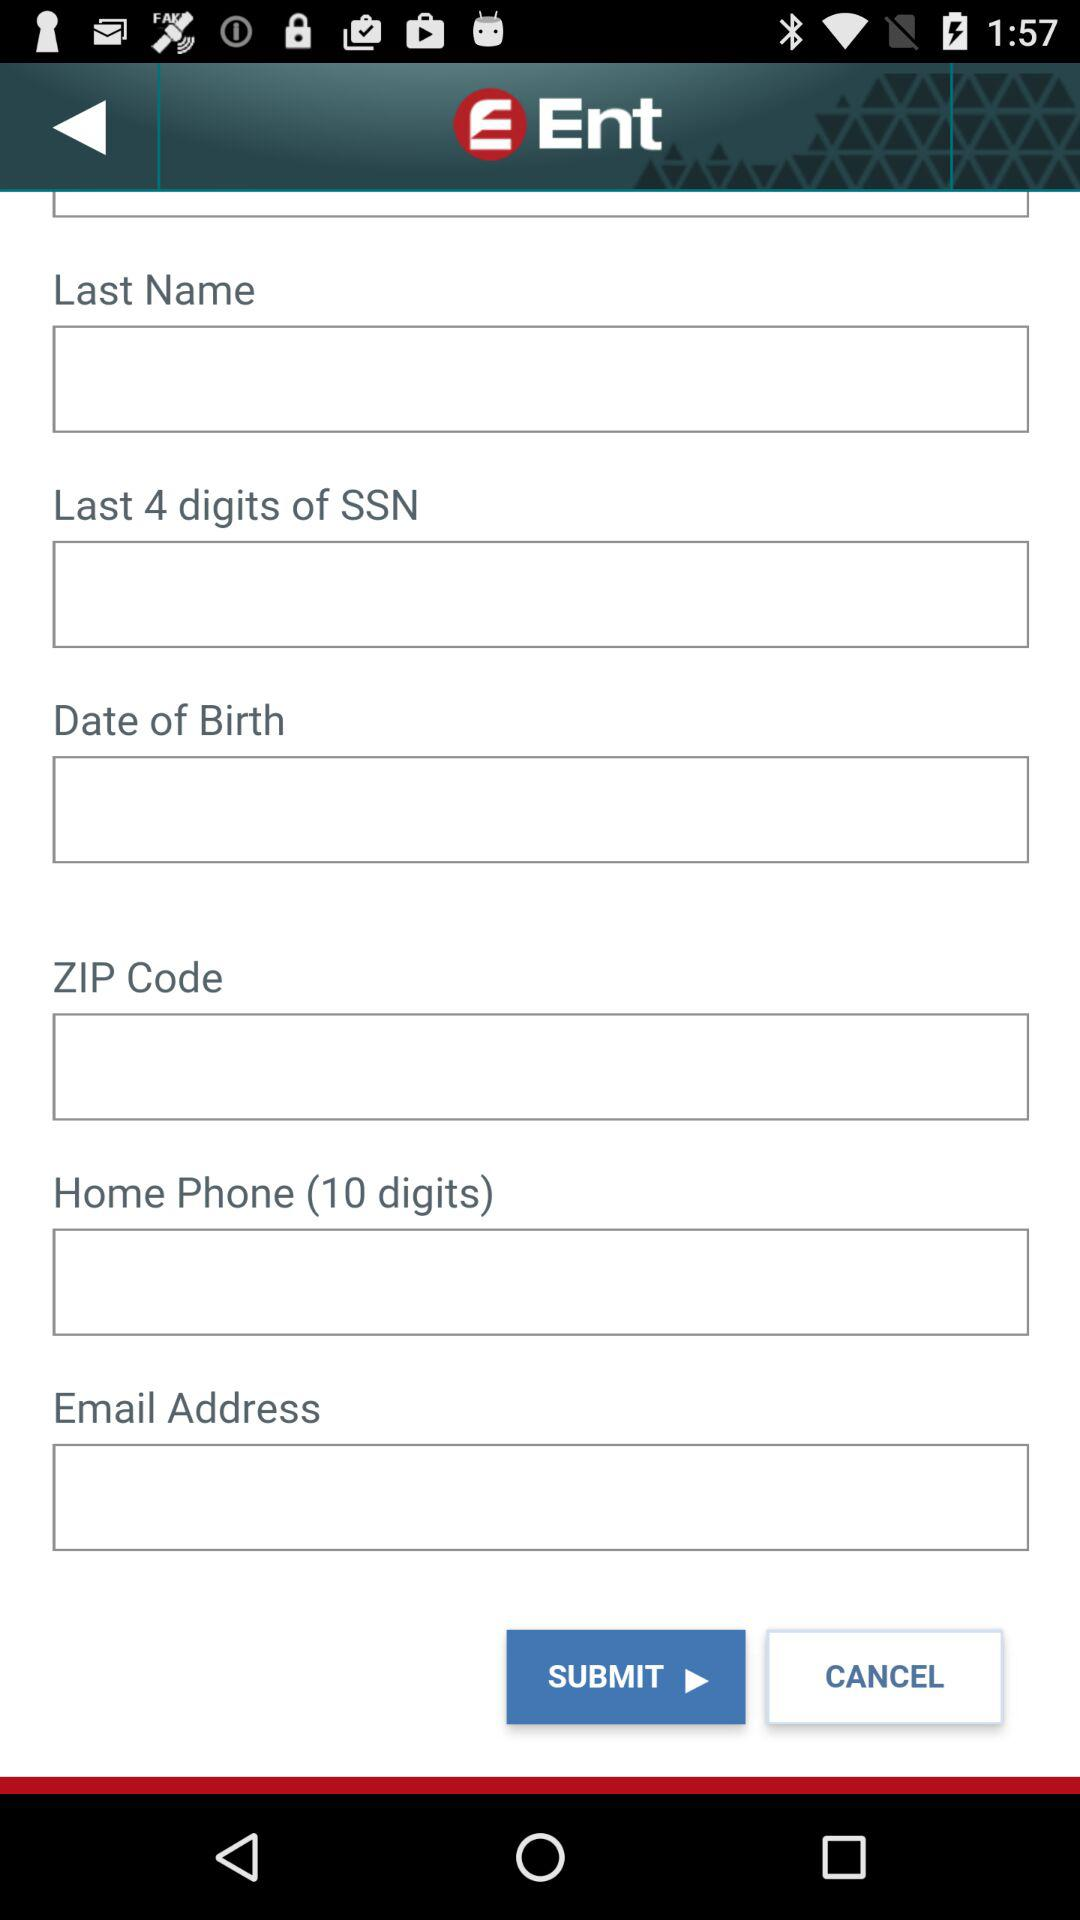What is the name of the application? The name of the application is "Ent". 